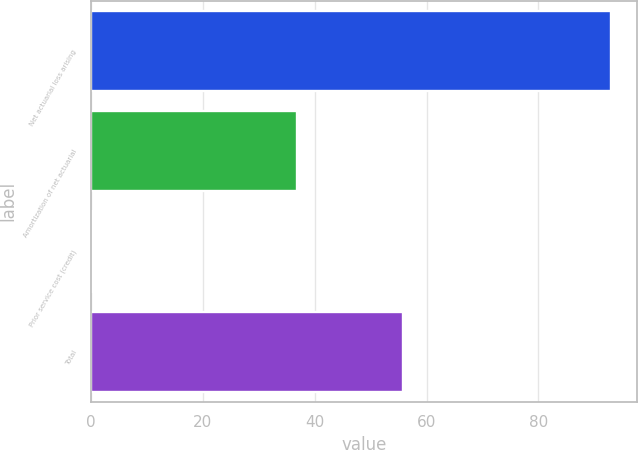Convert chart. <chart><loc_0><loc_0><loc_500><loc_500><bar_chart><fcel>Net actuarial loss arising<fcel>Amortization of net actuarial<fcel>Prior service cost (credit)<fcel>Total<nl><fcel>92.9<fcel>36.8<fcel>0.1<fcel>55.8<nl></chart> 